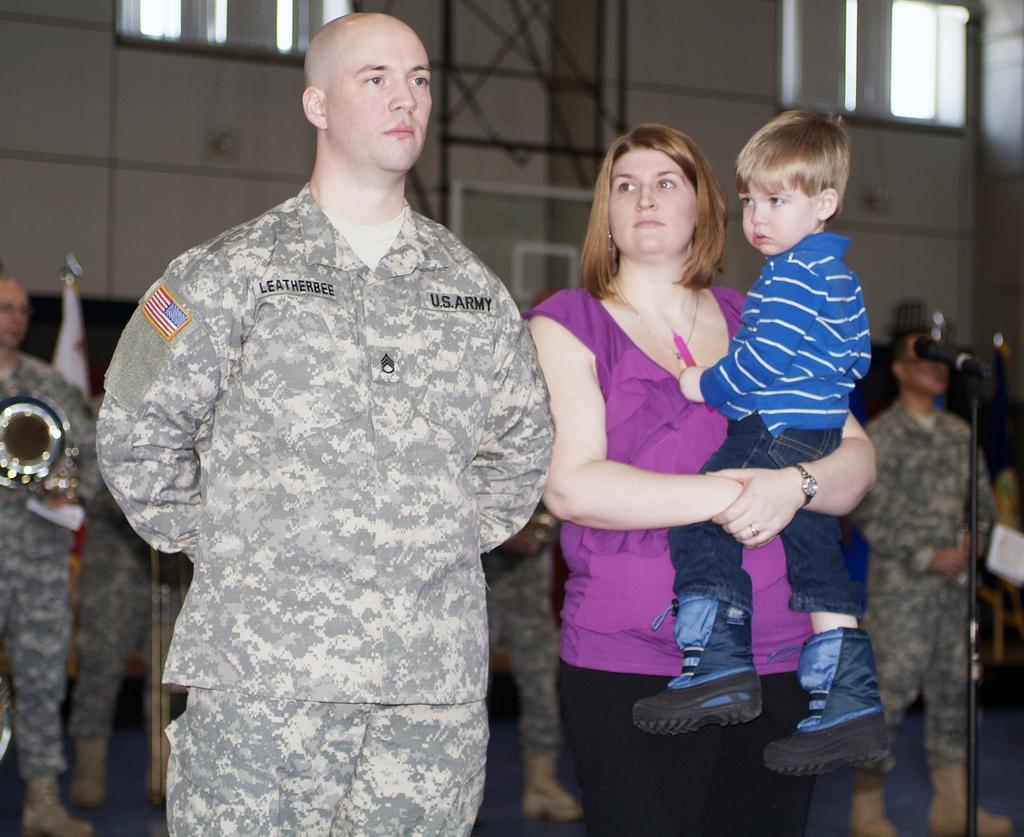Please provide a concise description of this image. In this image there is an army officer on the left side and there is a woman who is holding the kid on the right side. In the background there are few other army officers standing on the floor. On the right side there is a mic on the floor. In the background there is a wall to which there are windows. 